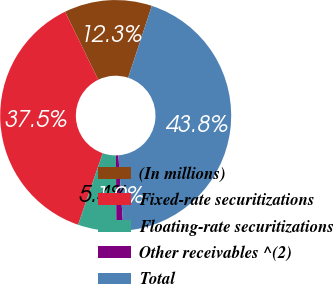Convert chart to OTSL. <chart><loc_0><loc_0><loc_500><loc_500><pie_chart><fcel>(In millions)<fcel>Fixed-rate securitizations<fcel>Floating-rate securitizations<fcel>Other receivables ^(2)<fcel>Total<nl><fcel>12.29%<fcel>37.51%<fcel>5.37%<fcel>0.98%<fcel>43.85%<nl></chart> 